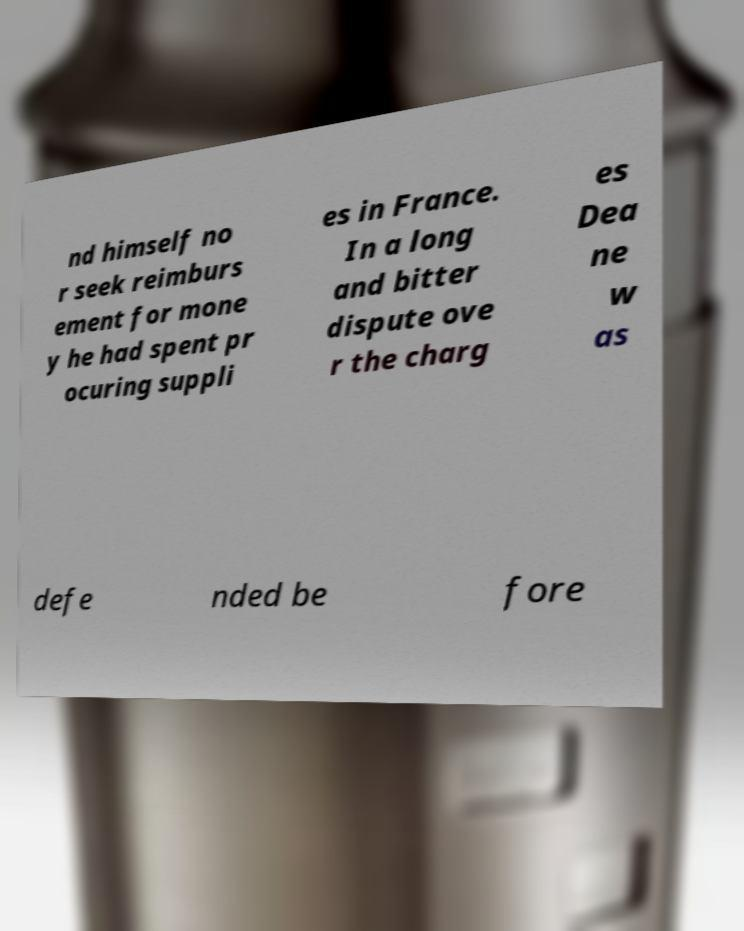Could you assist in decoding the text presented in this image and type it out clearly? nd himself no r seek reimburs ement for mone y he had spent pr ocuring suppli es in France. In a long and bitter dispute ove r the charg es Dea ne w as defe nded be fore 